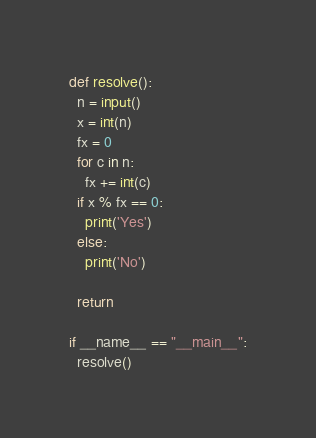Convert code to text. <code><loc_0><loc_0><loc_500><loc_500><_Python_>def resolve():
  n = input()
  x = int(n)
  fx = 0
  for c in n:
    fx += int(c)
  if x % fx == 0:
    print('Yes')
  else:
    print('No')

  return

if __name__ == "__main__":
  resolve()
</code> 